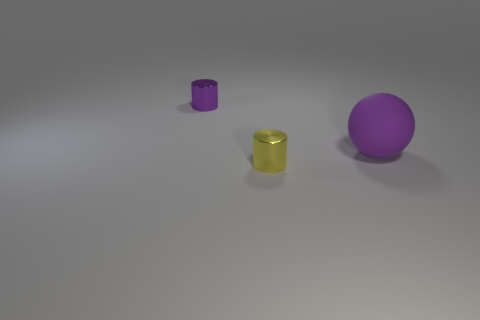How many small metal cylinders are in front of the thing that is in front of the big purple ball?
Provide a short and direct response. 0. How many shiny objects are blue cubes or yellow cylinders?
Offer a terse response. 1. Is there a small purple thing made of the same material as the small yellow cylinder?
Provide a short and direct response. Yes. What number of objects are cylinders right of the purple shiny cylinder or purple things that are to the right of the yellow metallic object?
Offer a very short reply. 2. Do the tiny cylinder that is behind the large purple thing and the big matte sphere have the same color?
Your answer should be compact. Yes. How many other things are the same color as the big matte thing?
Provide a short and direct response. 1. What is the material of the sphere?
Make the answer very short. Rubber. Do the cylinder to the right of the purple shiny thing and the ball have the same size?
Your response must be concise. No. Are there any other things that have the same size as the matte object?
Your response must be concise. No. Are there the same number of yellow things that are to the left of the small purple object and yellow shiny objects that are on the left side of the matte object?
Give a very brief answer. No. 